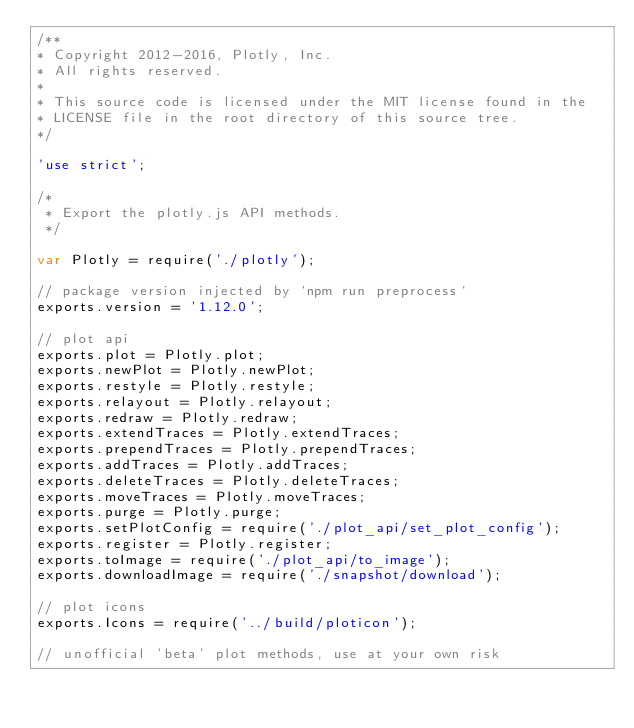<code> <loc_0><loc_0><loc_500><loc_500><_JavaScript_>/**
* Copyright 2012-2016, Plotly, Inc.
* All rights reserved.
*
* This source code is licensed under the MIT license found in the
* LICENSE file in the root directory of this source tree.
*/

'use strict';

/*
 * Export the plotly.js API methods.
 */

var Plotly = require('./plotly');

// package version injected by `npm run preprocess`
exports.version = '1.12.0';

// plot api
exports.plot = Plotly.plot;
exports.newPlot = Plotly.newPlot;
exports.restyle = Plotly.restyle;
exports.relayout = Plotly.relayout;
exports.redraw = Plotly.redraw;
exports.extendTraces = Plotly.extendTraces;
exports.prependTraces = Plotly.prependTraces;
exports.addTraces = Plotly.addTraces;
exports.deleteTraces = Plotly.deleteTraces;
exports.moveTraces = Plotly.moveTraces;
exports.purge = Plotly.purge;
exports.setPlotConfig = require('./plot_api/set_plot_config');
exports.register = Plotly.register;
exports.toImage = require('./plot_api/to_image');
exports.downloadImage = require('./snapshot/download');

// plot icons
exports.Icons = require('../build/ploticon');

// unofficial 'beta' plot methods, use at your own risk</code> 